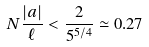Convert formula to latex. <formula><loc_0><loc_0><loc_500><loc_500>N \frac { | a | } { \ell } < \frac { 2 } { 5 ^ { 5 / 4 } } \simeq 0 . 2 7</formula> 